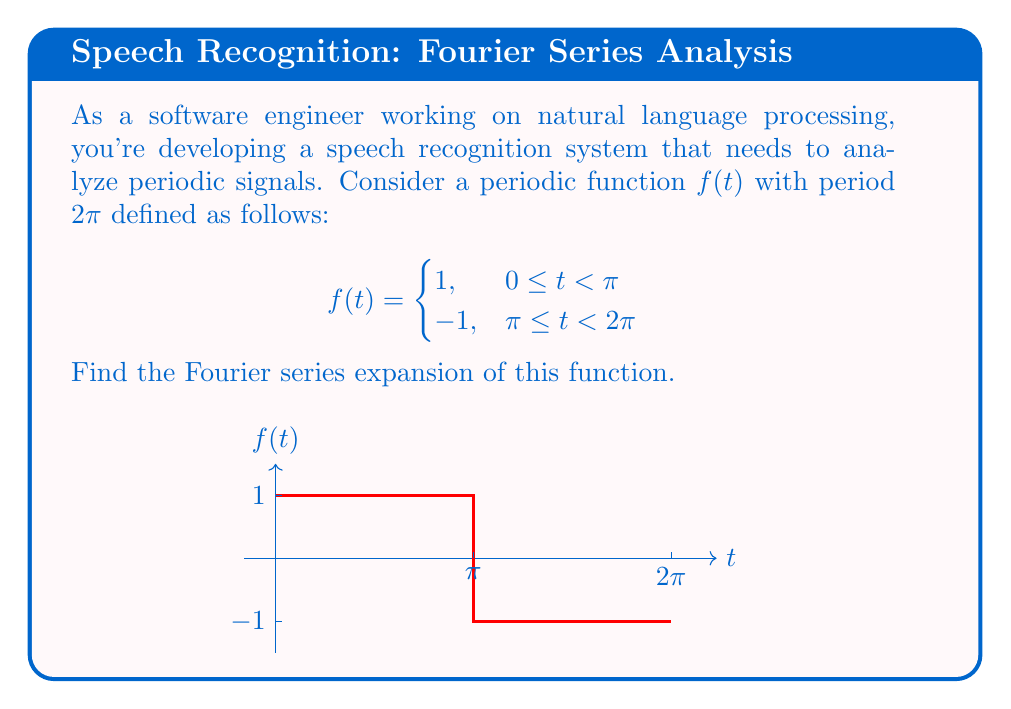Give your solution to this math problem. Let's approach this step-by-step:

1) The general form of a Fourier series is:

   $$f(t) = \frac{a_0}{2} + \sum_{n=1}^{\infty} (a_n \cos(nt) + b_n \sin(nt))$$

2) We need to calculate $a_0$, $a_n$, and $b_n$:

   $$a_0 = \frac{1}{\pi} \int_{0}^{2\pi} f(t) dt$$
   $$a_n = \frac{1}{\pi} \int_{0}^{2\pi} f(t) \cos(nt) dt$$
   $$b_n = \frac{1}{\pi} \int_{0}^{2\pi} f(t) \sin(nt) dt$$

3) Let's start with $a_0$:

   $$a_0 = \frac{1}{\pi} \left(\int_{0}^{\pi} 1 dt + \int_{\pi}^{2\pi} (-1) dt\right) = \frac{1}{\pi} (\pi - \pi) = 0$$

4) For $a_n$:

   $$a_n = \frac{1}{\pi} \left(\int_{0}^{\pi} \cos(nt) dt - \int_{\pi}^{2\pi} \cos(nt) dt\right)$$
   $$= \frac{1}{\pi} \left[\frac{\sin(nt)}{n}\right]_{0}^{\pi} - \frac{1}{\pi} \left[\frac{\sin(nt)}{n}\right]_{\pi}^{2\pi} = 0$$

5) For $b_n$:

   $$b_n = \frac{1}{\pi} \left(\int_{0}^{\pi} \sin(nt) dt - \int_{\pi}^{2\pi} \sin(nt) dt\right)$$
   $$= \frac{1}{\pi} \left[-\frac{\cos(nt)}{n}\right]_{0}^{\pi} + \frac{1}{\pi} \left[\frac{\cos(nt)}{n}\right]_{\pi}^{2\pi}$$
   $$= \frac{1}{\pi n} (-\cos(n\pi) + 1 + \cos(2n\pi) - \cos(n\pi))$$
   $$= \frac{2}{\pi n} (1 - \cos(n\pi)) = \begin{cases}
   0, & \text{if } n \text{ is even} \\
   \frac{4}{\pi n}, & \text{if } n \text{ is odd}
   \end{cases}$$

6) Therefore, the Fourier series expansion is:

   $$f(t) = \sum_{n=1, n \text{ odd}}^{\infty} \frac{4}{\pi n} \sin(nt)$$
Answer: $$f(t) = \sum_{n=1, n \text{ odd}}^{\infty} \frac{4}{\pi n} \sin(nt)$$ 